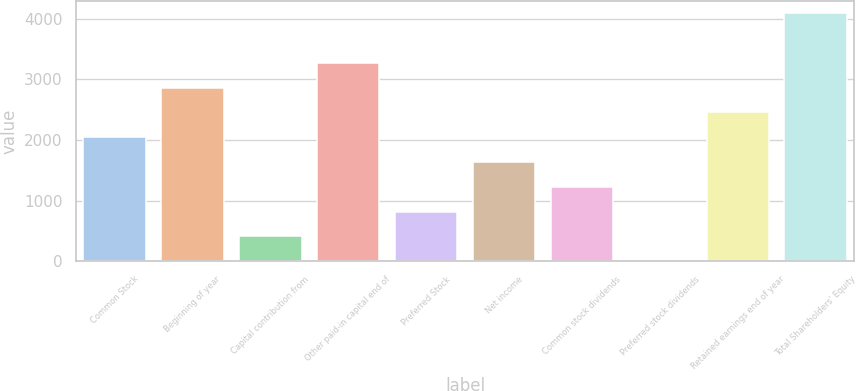Convert chart. <chart><loc_0><loc_0><loc_500><loc_500><bar_chart><fcel>Common Stock<fcel>Beginning of year<fcel>Capital contribution from<fcel>Other paid-in capital end of<fcel>Preferred Stock<fcel>Net income<fcel>Common stock dividends<fcel>Preferred stock dividends<fcel>Retained earnings end of year<fcel>Total Shareholders' Equity<nl><fcel>2046.5<fcel>2863.9<fcel>411.7<fcel>3272.6<fcel>820.4<fcel>1637.8<fcel>1229.1<fcel>3<fcel>2455.2<fcel>4090<nl></chart> 